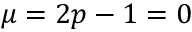Convert formula to latex. <formula><loc_0><loc_0><loc_500><loc_500>\mu = 2 p - 1 = 0</formula> 